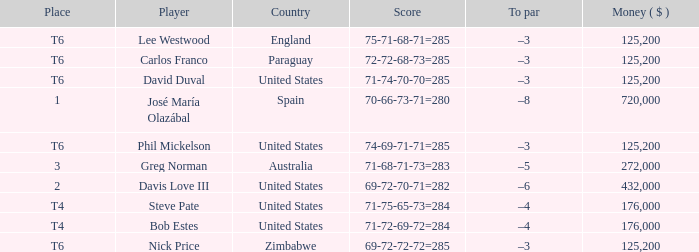Which average money has a Score of 69-72-72-72=285? 125200.0. 